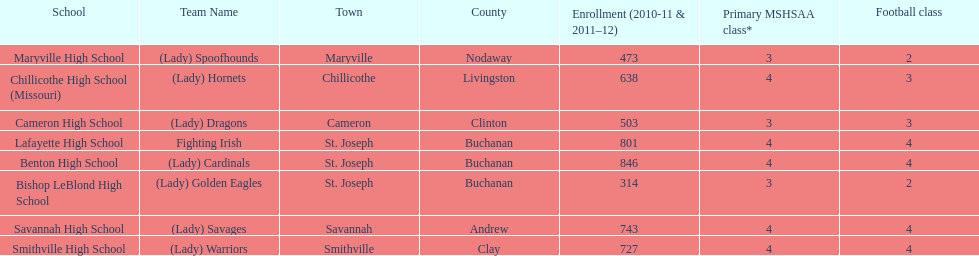Does lafayette high school or benton high school have green and grey as their colors? Lafayette High School. 